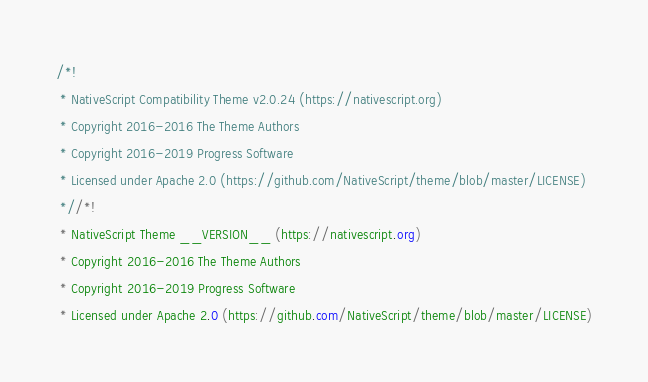Convert code to text. <code><loc_0><loc_0><loc_500><loc_500><_CSS_>/*!
 * NativeScript Compatibility Theme v2.0.24 (https://nativescript.org)
 * Copyright 2016-2016 The Theme Authors
 * Copyright 2016-2019 Progress Software
 * Licensed under Apache 2.0 (https://github.com/NativeScript/theme/blob/master/LICENSE)
 *//*!
 * NativeScript Theme __VERSION__ (https://nativescript.org)
 * Copyright 2016-2016 The Theme Authors
 * Copyright 2016-2019 Progress Software
 * Licensed under Apache 2.0 (https://github.com/NativeScript/theme/blob/master/LICENSE)</code> 